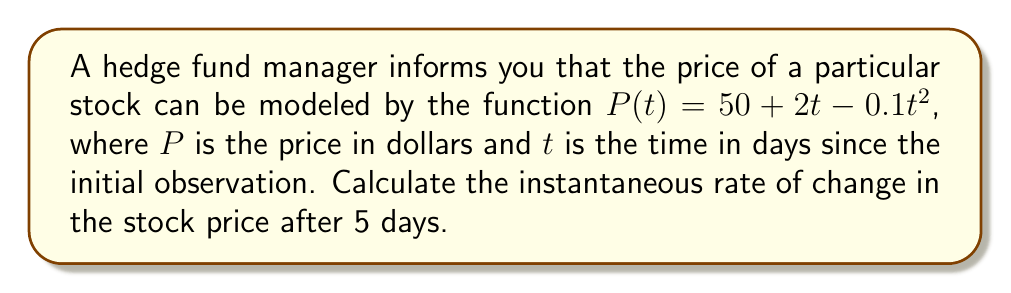Can you solve this math problem? To find the instantaneous rate of change in the stock price, we need to calculate the derivative of the price function $P(t)$ and evaluate it at $t = 5$.

Step 1: Find the derivative of $P(t)$.
$$\frac{d}{dt}P(t) = \frac{d}{dt}(50 + 2t - 0.1t^2)$$
$$P'(t) = 0 + 2 - 0.2t$$
$$P'(t) = 2 - 0.2t$$

Step 2: Evaluate the derivative at $t = 5$.
$$P'(5) = 2 - 0.2(5)$$
$$P'(5) = 2 - 1$$
$$P'(5) = 1$$

The instantaneous rate of change is the value of the derivative at the given point. In this case, it's $1$ dollar per day after 5 days.
Answer: $1 dollar per day 